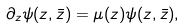<formula> <loc_0><loc_0><loc_500><loc_500>\partial _ { z } \psi ( z , \bar { z } ) = \mu ( z ) \psi ( z , \bar { z } ) ,</formula> 